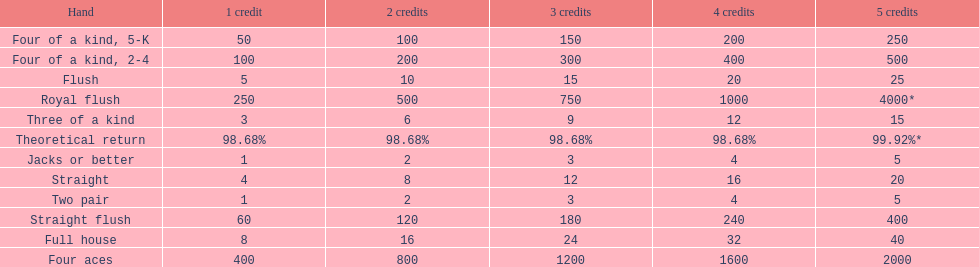How many straight wins at 3 credits equals one straight flush win at two credits? 10. 